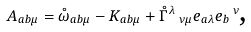Convert formula to latex. <formula><loc_0><loc_0><loc_500><loc_500>A _ { a b \mu } = \mathring { \omega } _ { a b \mu } - K _ { a b \mu } + \mathring { \Gamma } ^ { \lambda } \, _ { \nu \mu } e _ { a \lambda } e _ { b } \, ^ { \nu } \text {,}</formula> 